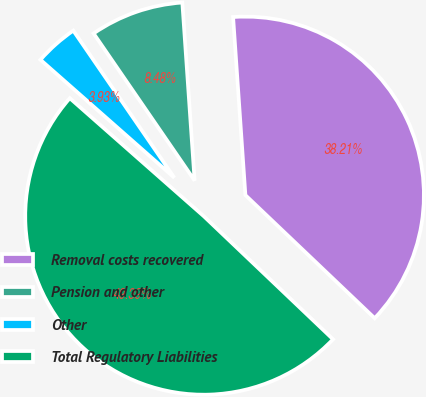Convert chart. <chart><loc_0><loc_0><loc_500><loc_500><pie_chart><fcel>Removal costs recovered<fcel>Pension and other<fcel>Other<fcel>Total Regulatory Liabilities<nl><fcel>38.21%<fcel>8.48%<fcel>3.93%<fcel>49.39%<nl></chart> 